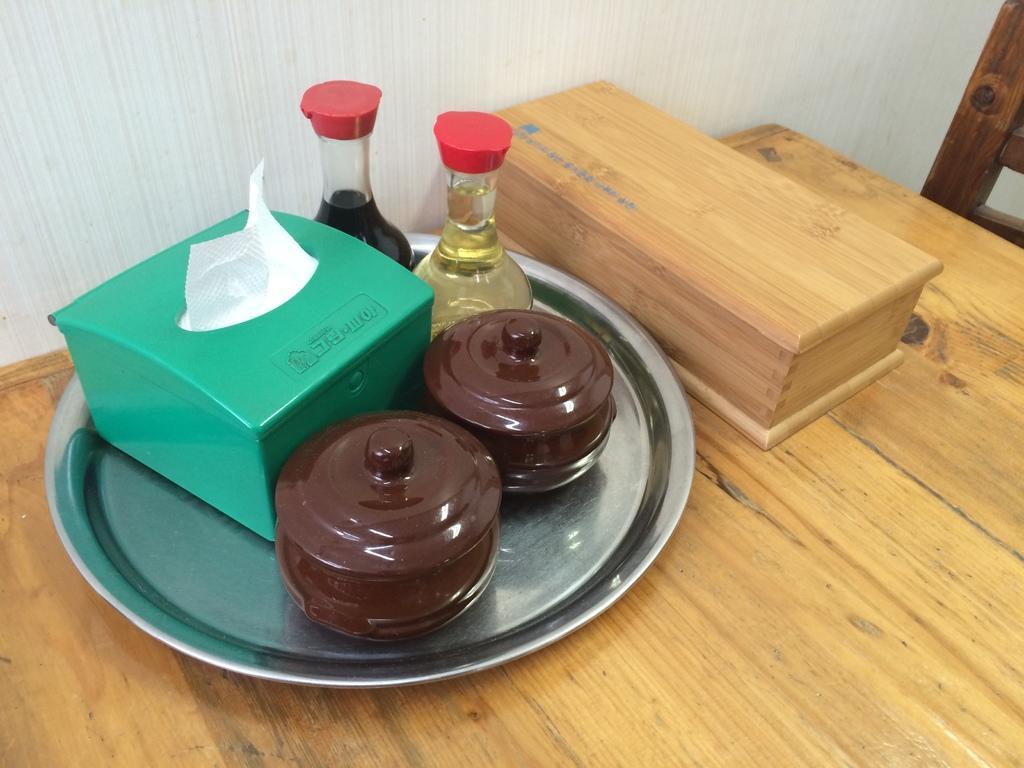Can you describe this image briefly? In this image there is a wooden table. On the table there is a plate. On the plate there are jars, bottles and a box. There are tissues in the box. Beside the plate there is a wooden box. Behind the table there is a wall. 